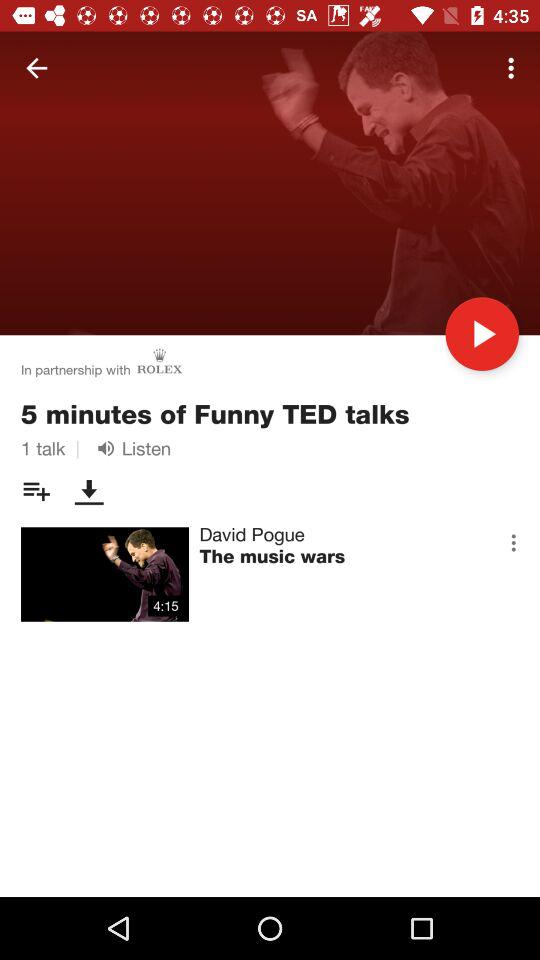What is the name of the TED Talk? The name of the TED Talk is "The music wars". 